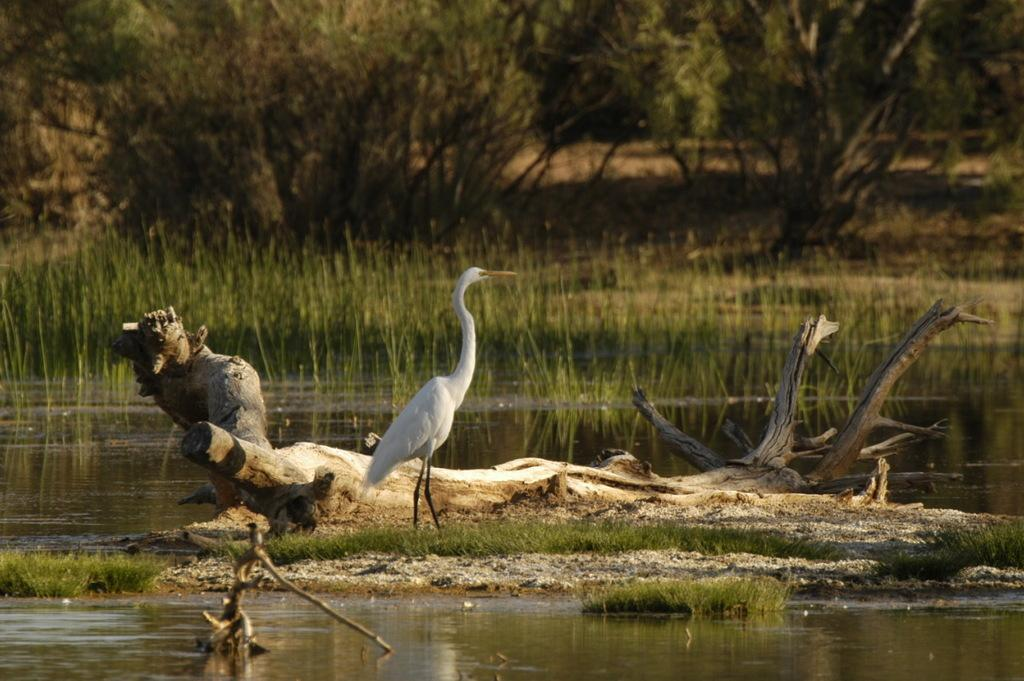What is the primary element in the image? There is water in the image. What type of animal can be seen in the image? There is a bird in the image. What type of vegetation is visible in the image? There is grass visible in the image. What can be seen in the background of the image? There are trees in the background of the image. What type of anger is the bird expressing in the image? There is no indication of anger in the image; the bird is simply present in the water. 